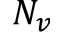<formula> <loc_0><loc_0><loc_500><loc_500>N _ { v }</formula> 